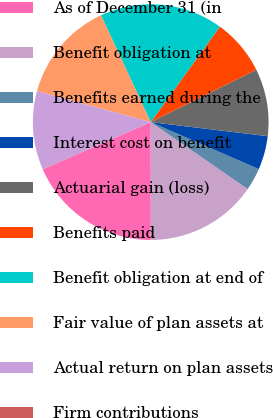Convert chart to OTSL. <chart><loc_0><loc_0><loc_500><loc_500><pie_chart><fcel>As of December 31 (in<fcel>Benefit obligation at<fcel>Benefits earned during the<fcel>Interest cost on benefit<fcel>Actuarial gain (loss)<fcel>Benefits paid<fcel>Benefit obligation at end of<fcel>Fair value of plan assets at<fcel>Actual return on plan assets<fcel>Firm contributions<nl><fcel>18.45%<fcel>15.38%<fcel>3.09%<fcel>4.62%<fcel>9.23%<fcel>7.7%<fcel>16.91%<fcel>13.84%<fcel>10.77%<fcel>0.02%<nl></chart> 